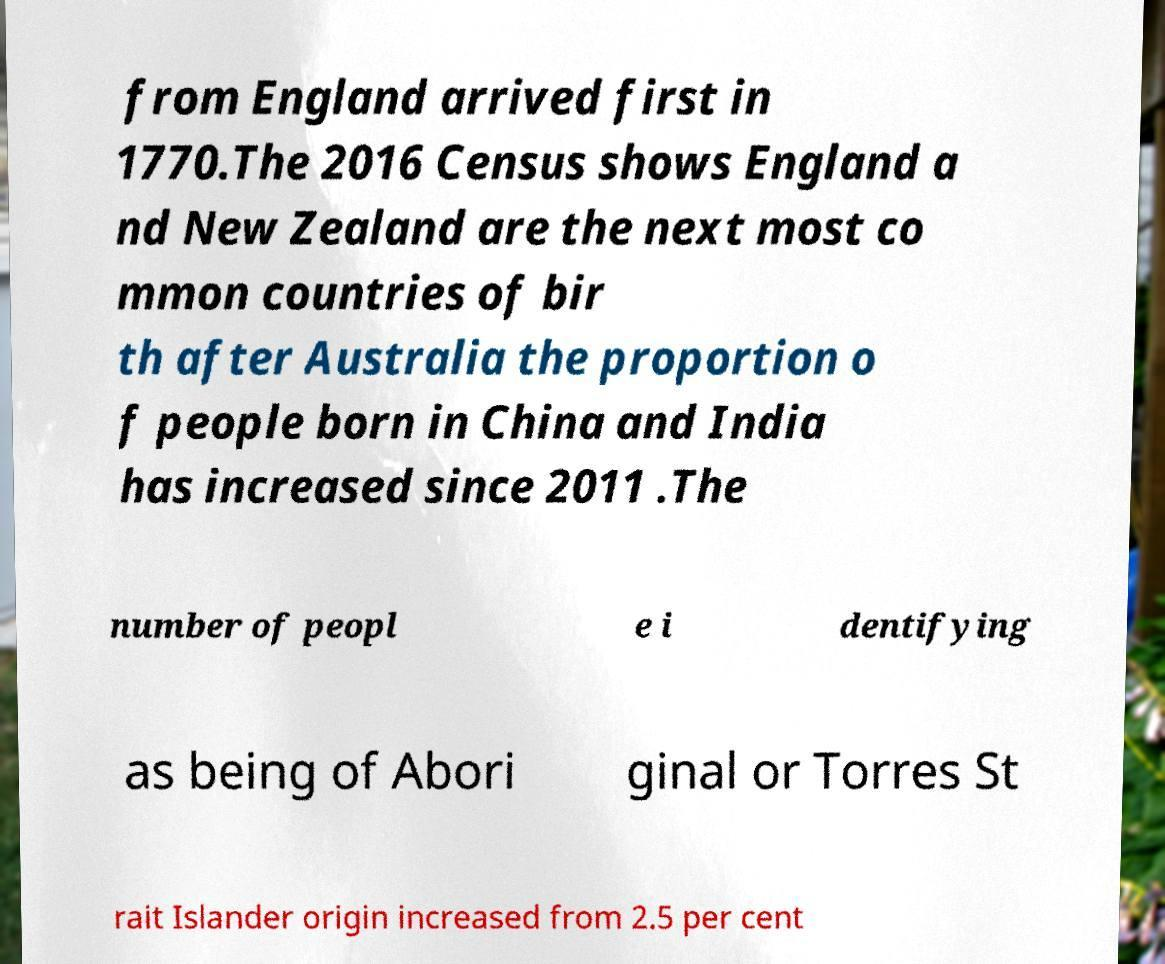Could you extract and type out the text from this image? from England arrived first in 1770.The 2016 Census shows England a nd New Zealand are the next most co mmon countries of bir th after Australia the proportion o f people born in China and India has increased since 2011 .The number of peopl e i dentifying as being of Abori ginal or Torres St rait Islander origin increased from 2.5 per cent 